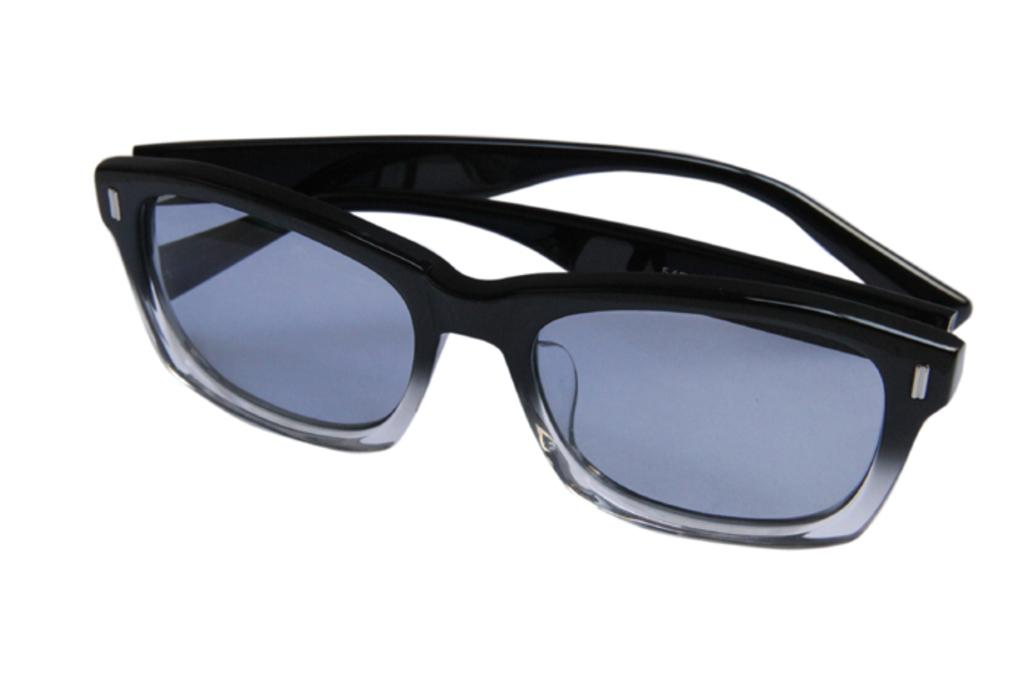What type of accessory is present in the image? There are sunglasses in the image. What color are the sunglasses? The sunglasses are black in color. Can you see a pear being eaten by someone wearing the sunglasses in the image? There is no pear or person wearing the sunglasses present in the image. 